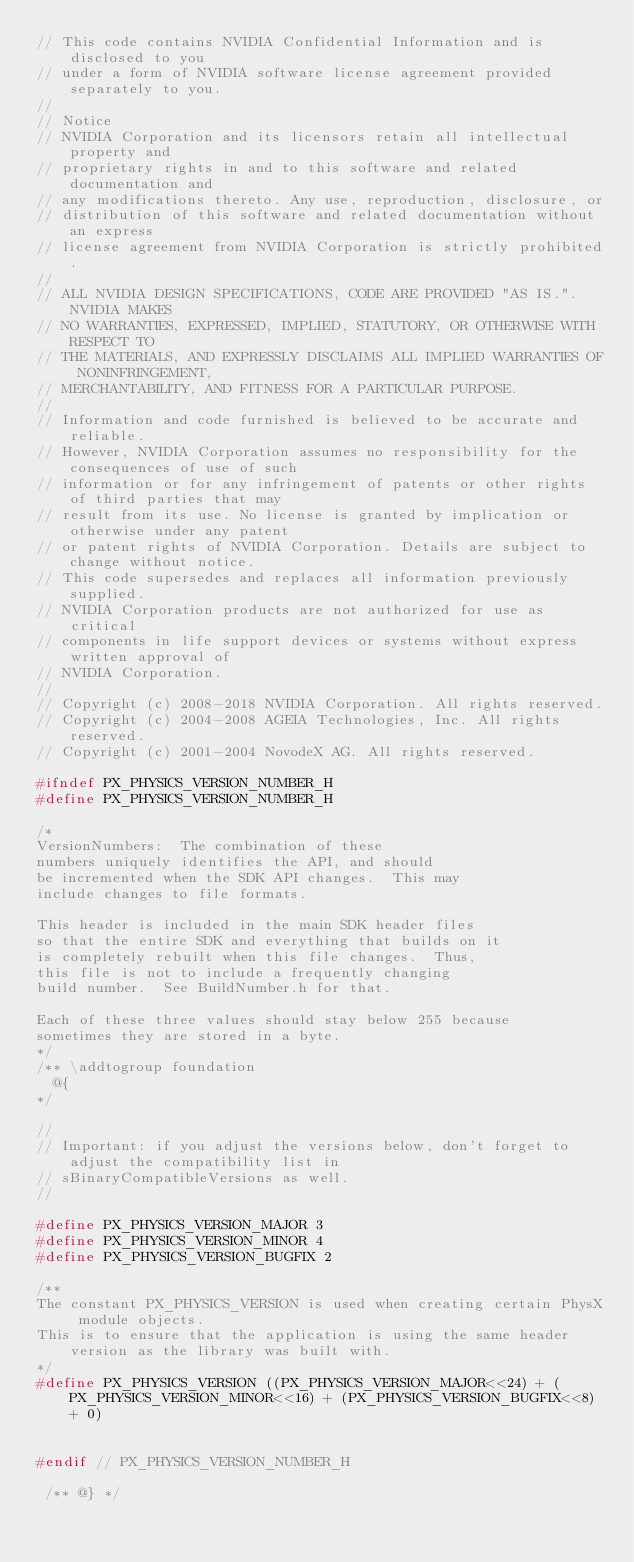Convert code to text. <code><loc_0><loc_0><loc_500><loc_500><_C_>// This code contains NVIDIA Confidential Information and is disclosed to you
// under a form of NVIDIA software license agreement provided separately to you.
//
// Notice
// NVIDIA Corporation and its licensors retain all intellectual property and
// proprietary rights in and to this software and related documentation and
// any modifications thereto. Any use, reproduction, disclosure, or
// distribution of this software and related documentation without an express
// license agreement from NVIDIA Corporation is strictly prohibited.
//
// ALL NVIDIA DESIGN SPECIFICATIONS, CODE ARE PROVIDED "AS IS.". NVIDIA MAKES
// NO WARRANTIES, EXPRESSED, IMPLIED, STATUTORY, OR OTHERWISE WITH RESPECT TO
// THE MATERIALS, AND EXPRESSLY DISCLAIMS ALL IMPLIED WARRANTIES OF NONINFRINGEMENT,
// MERCHANTABILITY, AND FITNESS FOR A PARTICULAR PURPOSE.
//
// Information and code furnished is believed to be accurate and reliable.
// However, NVIDIA Corporation assumes no responsibility for the consequences of use of such
// information or for any infringement of patents or other rights of third parties that may
// result from its use. No license is granted by implication or otherwise under any patent
// or patent rights of NVIDIA Corporation. Details are subject to change without notice.
// This code supersedes and replaces all information previously supplied.
// NVIDIA Corporation products are not authorized for use as critical
// components in life support devices or systems without express written approval of
// NVIDIA Corporation.
//
// Copyright (c) 2008-2018 NVIDIA Corporation. All rights reserved.
// Copyright (c) 2004-2008 AGEIA Technologies, Inc. All rights reserved.
// Copyright (c) 2001-2004 NovodeX AG. All rights reserved.  

#ifndef PX_PHYSICS_VERSION_NUMBER_H
#define PX_PHYSICS_VERSION_NUMBER_H

/*
VersionNumbers:  The combination of these
numbers uniquely identifies the API, and should
be incremented when the SDK API changes.  This may
include changes to file formats.

This header is included in the main SDK header files
so that the entire SDK and everything that builds on it
is completely rebuilt when this file changes.  Thus,
this file is not to include a frequently changing
build number.  See BuildNumber.h for that.

Each of these three values should stay below 255 because
sometimes they are stored in a byte.
*/
/** \addtogroup foundation
  @{
*/

//
// Important: if you adjust the versions below, don't forget to adjust the compatibility list in
// sBinaryCompatibleVersions as well.
//

#define PX_PHYSICS_VERSION_MAJOR 3
#define PX_PHYSICS_VERSION_MINOR 4
#define PX_PHYSICS_VERSION_BUGFIX 2

/**
The constant PX_PHYSICS_VERSION is used when creating certain PhysX module objects.
This is to ensure that the application is using the same header version as the library was built with.
*/
#define PX_PHYSICS_VERSION ((PX_PHYSICS_VERSION_MAJOR<<24) + (PX_PHYSICS_VERSION_MINOR<<16) + (PX_PHYSICS_VERSION_BUGFIX<<8) + 0)


#endif // PX_PHYSICS_VERSION_NUMBER_H

 /** @} */
</code> 